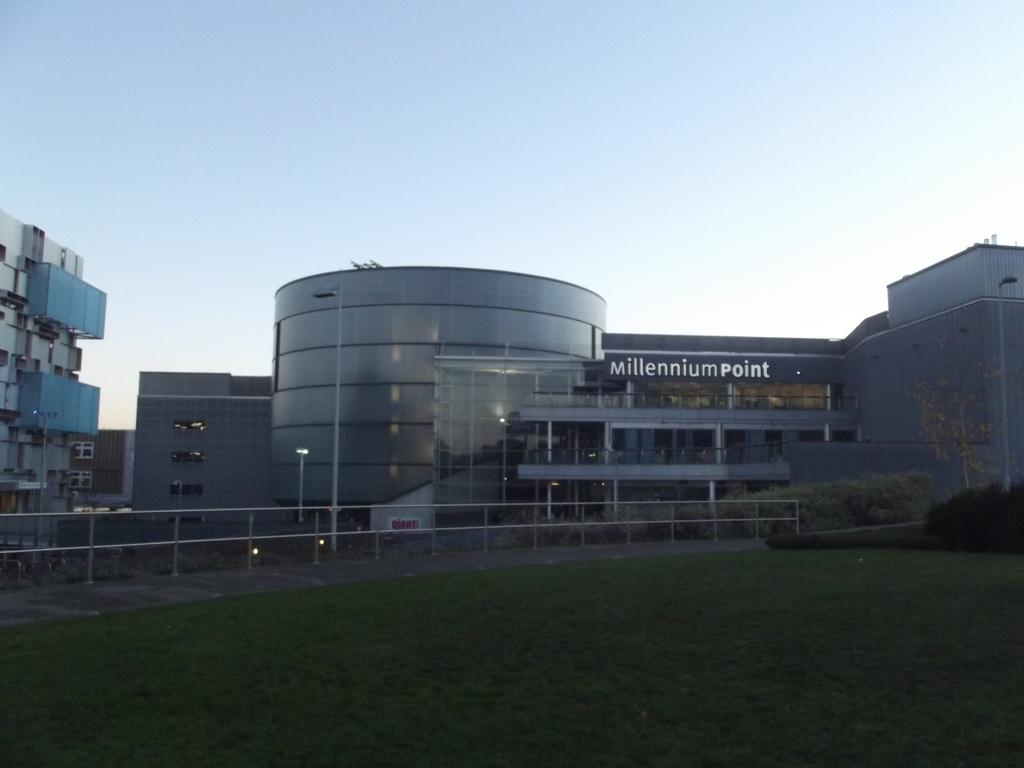What type of landscape is depicted in the image? There is a grassland in the image. What can be seen in the background of the grassland? There are plants, a railing, buildings, and the sky visible in the background of the image. Can you see a squirrel holding a notebook and a nut in the image? There is no squirrel, notebook, or nut present in the image. 